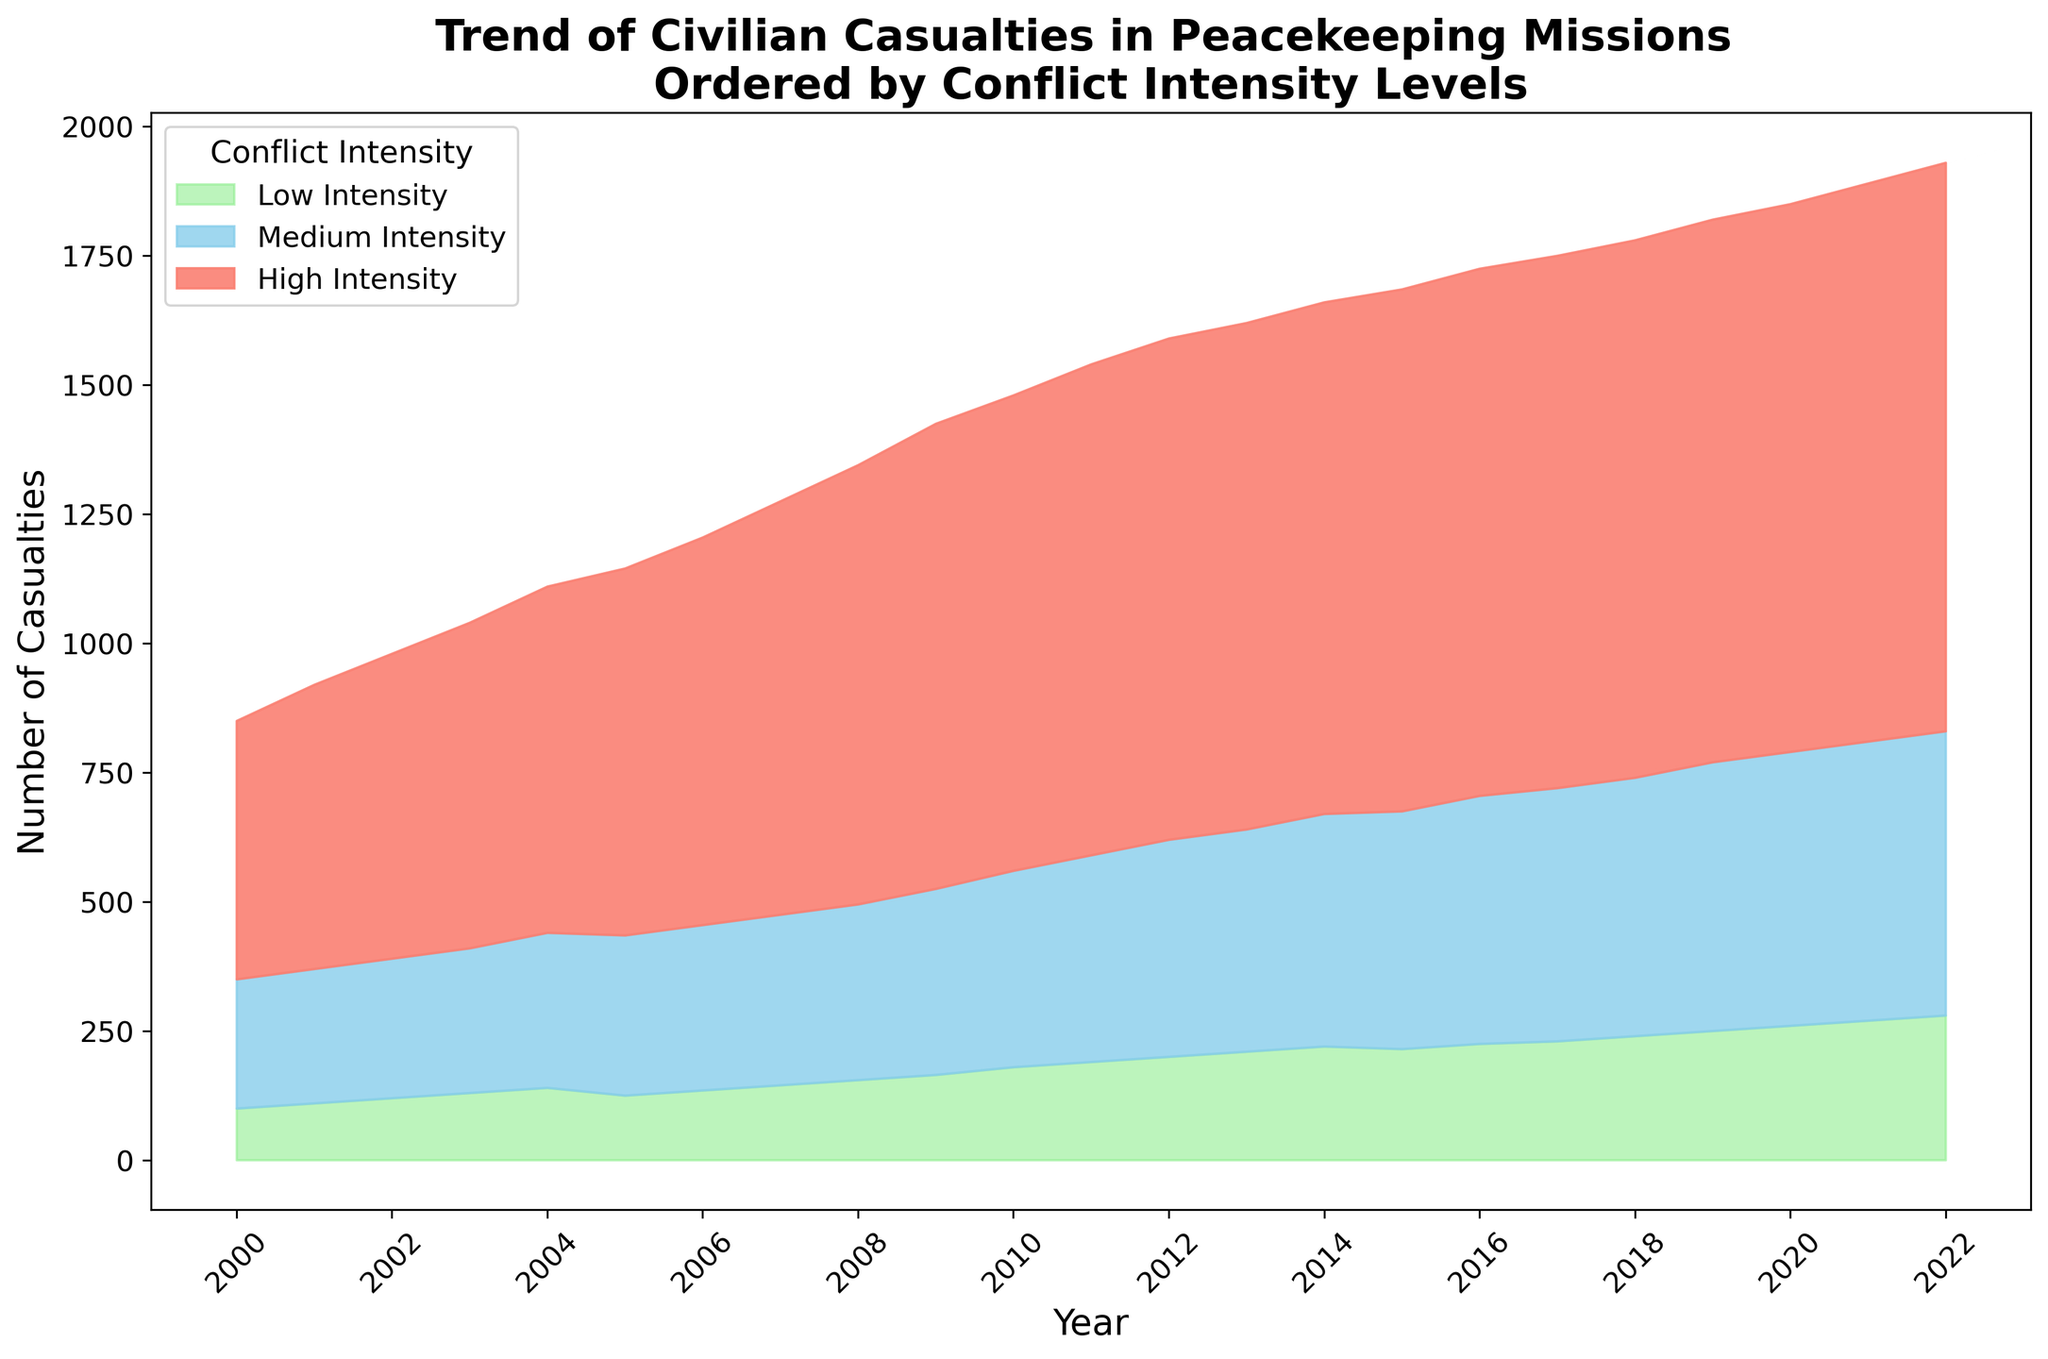What is the main trend observed in civilian casualties from 2000 to 2022 for high-intensity conflicts? The chart shows the number of civilian casualties for high-intensity conflicts increasing each year from 2000 to 2022. Despite some minor fluctuations, there is a clear and consistent upward trend overall.
Answer: Increasing Compare the civilian casualties in low-intensity conflicts between the years 2010 and 2020. In 2010, the number of civilian casualties in low-intensity conflicts is 180. In 2020, the number is 260. There is an increase of 80 casualties over the ten-year period.
Answer: Higher in 2020 How do the civilian casualties in medium-intensity conflicts in 2005 compare to those in low-intensity conflicts in the same year? The chart shows there are 310 casualties in medium-intensity conflicts and 125 casualties in low-intensity conflicts in the year 2005. The medium-intensity conflicts have significantly more casualties.
Answer: Medium-intensity conflicts have more In which year did the number of civilian casualties in medium-intensity conflicts reach 500? Visual inspection of the chart shows that the number of civilian casualties in medium-intensity conflicts reached 500 in the year 2018.
Answer: 2018 Between 2000 and 2020, in which conflict intensity category did the number of civilian casualties increase the most? By visually comparing the three colored regions representing different conflict intensities, it is clear that the high-intensity conflicts category saw the largest increase in casualties from 2000 to 2020.
Answer: High-intensity conflicts What is the color used to represent low-intensity conflicts, and how does this help distinguish it? The color used to represent low-intensity conflicts in the chart is light green. This distinct color helps differentiate the low-intensity conflict casualties from the medium (sky blue) and high-intensity (salmon) conflicts.
Answer: Light green Which year marks the first time civilian casualties in high-intensity conflicts surpassed 1000? By examining the chart, we see that the civilian casualties in high-intensity conflicts reached 1030 in the year 2017, marking the first time the figure surpassed 1000.
Answer: 2017 